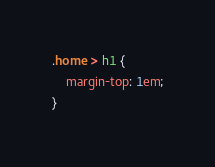<code> <loc_0><loc_0><loc_500><loc_500><_CSS_>.home > h1 {
	margin-top: 1em;
}</code> 